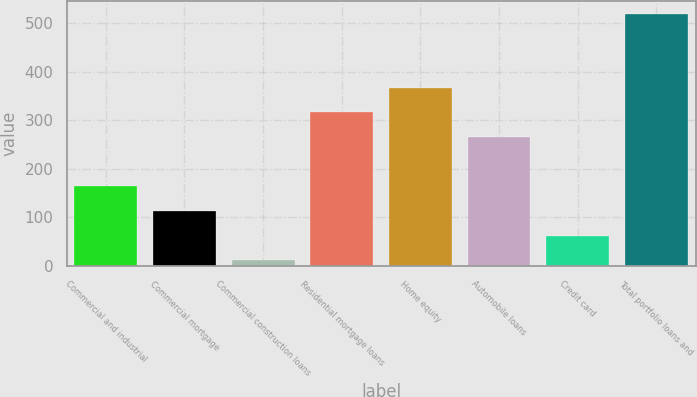<chart> <loc_0><loc_0><loc_500><loc_500><bar_chart><fcel>Commercial and industrial<fcel>Commercial mortgage<fcel>Commercial construction loans<fcel>Residential mortgage loans<fcel>Home equity<fcel>Automobile loans<fcel>Credit card<fcel>Total portfolio loans and<nl><fcel>164.1<fcel>113.4<fcel>12<fcel>316.2<fcel>366.9<fcel>265.5<fcel>62.7<fcel>519<nl></chart> 